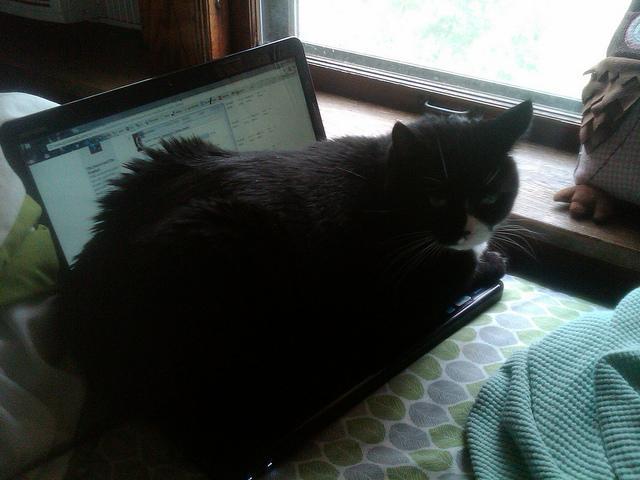How many women are in this photo?
Give a very brief answer. 0. 